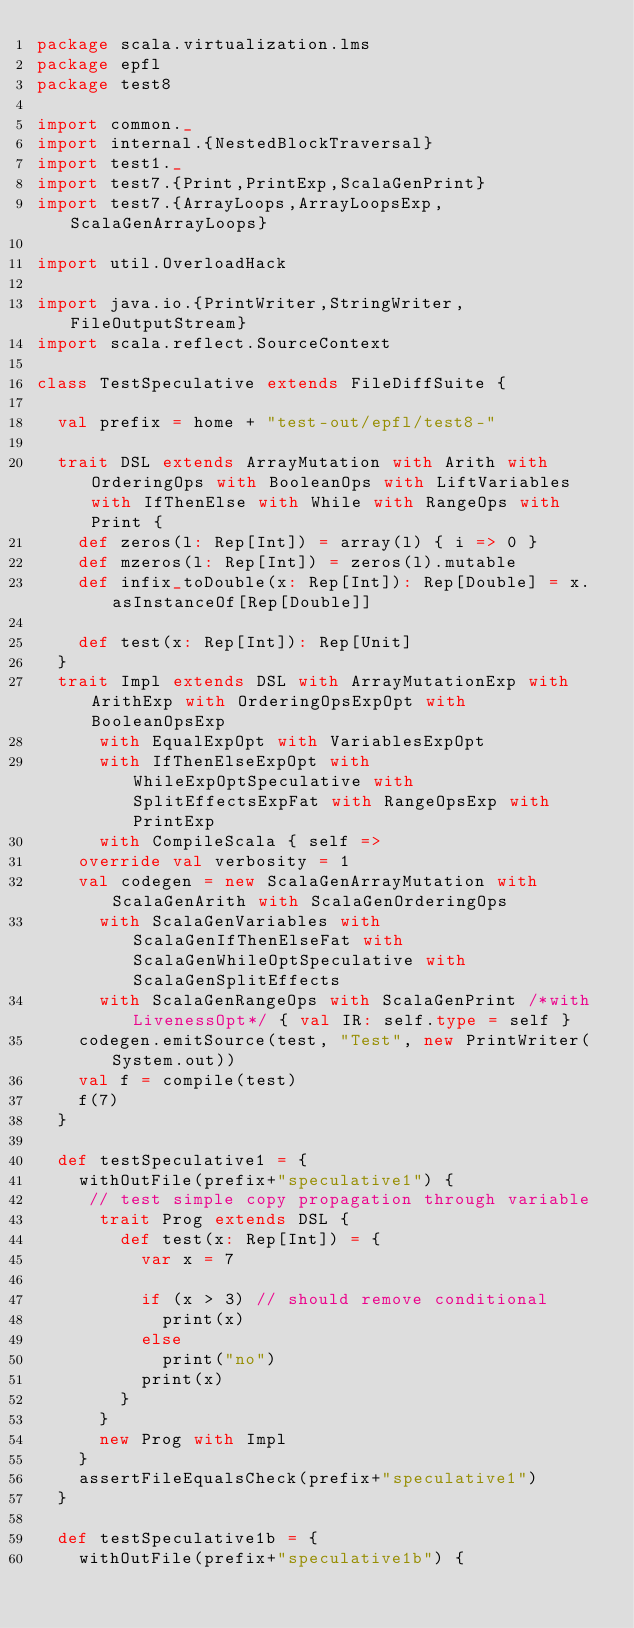<code> <loc_0><loc_0><loc_500><loc_500><_Scala_>package scala.virtualization.lms
package epfl
package test8

import common._
import internal.{NestedBlockTraversal}
import test1._
import test7.{Print,PrintExp,ScalaGenPrint}
import test7.{ArrayLoops,ArrayLoopsExp,ScalaGenArrayLoops}

import util.OverloadHack

import java.io.{PrintWriter,StringWriter,FileOutputStream}
import scala.reflect.SourceContext

class TestSpeculative extends FileDiffSuite {
  
  val prefix = home + "test-out/epfl/test8-"
  
  trait DSL extends ArrayMutation with Arith with OrderingOps with BooleanOps with LiftVariables with IfThenElse with While with RangeOps with Print {
    def zeros(l: Rep[Int]) = array(l) { i => 0 }
    def mzeros(l: Rep[Int]) = zeros(l).mutable
    def infix_toDouble(x: Rep[Int]): Rep[Double] = x.asInstanceOf[Rep[Double]]

    def test(x: Rep[Int]): Rep[Unit]
  }
  trait Impl extends DSL with ArrayMutationExp with ArithExp with OrderingOpsExpOpt with BooleanOpsExp 
      with EqualExpOpt with VariablesExpOpt 
      with IfThenElseExpOpt with WhileExpOptSpeculative with SplitEffectsExpFat with RangeOpsExp with PrintExp 
      with CompileScala { self => 
    override val verbosity = 1
    val codegen = new ScalaGenArrayMutation with ScalaGenArith with ScalaGenOrderingOps 
      with ScalaGenVariables with ScalaGenIfThenElseFat with ScalaGenWhileOptSpeculative with ScalaGenSplitEffects
      with ScalaGenRangeOps with ScalaGenPrint /*with LivenessOpt*/ { val IR: self.type = self }
    codegen.emitSource(test, "Test", new PrintWriter(System.out))
    val f = compile(test)
    f(7)
  }
  
  def testSpeculative1 = {
    withOutFile(prefix+"speculative1") {
     // test simple copy propagation through variable
      trait Prog extends DSL {
        def test(x: Rep[Int]) = {
          var x = 7
          
          if (x > 3) // should remove conditional
            print(x)
          else
            print("no")
          print(x)
        }
      }
      new Prog with Impl
    }
    assertFileEqualsCheck(prefix+"speculative1")
  }

  def testSpeculative1b = {
    withOutFile(prefix+"speculative1b") {</code> 